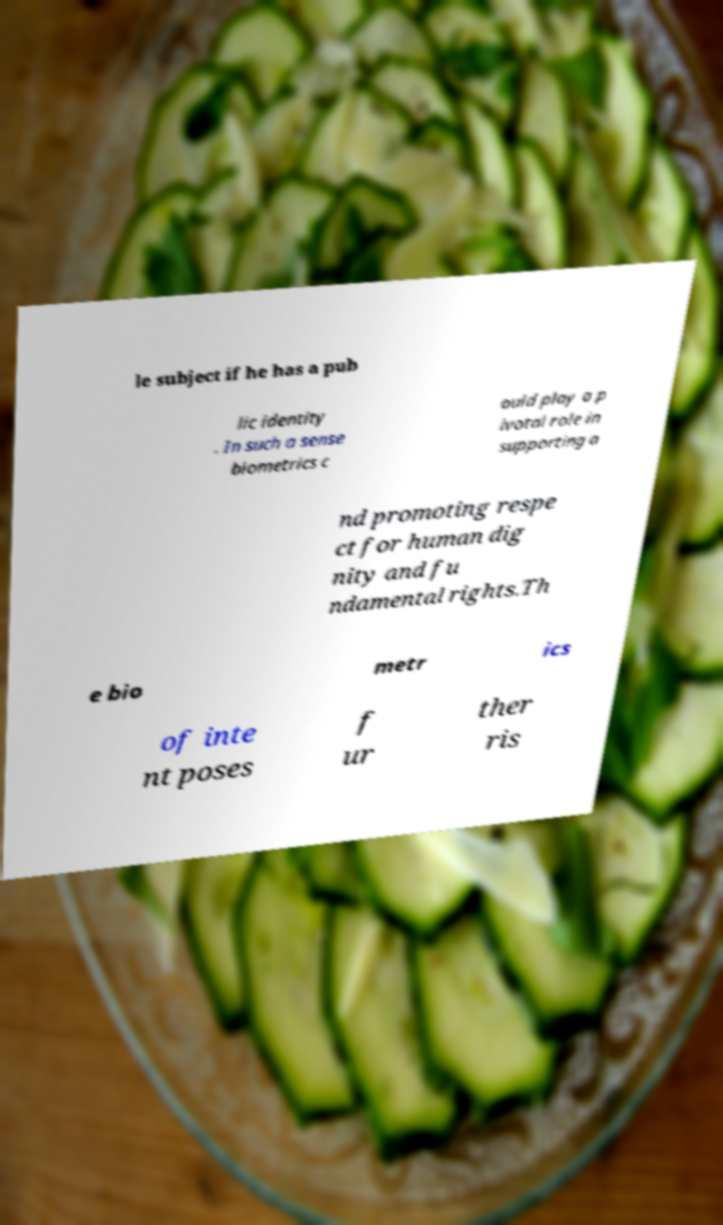Could you assist in decoding the text presented in this image and type it out clearly? le subject if he has a pub lic identity . In such a sense biometrics c ould play a p ivotal role in supporting a nd promoting respe ct for human dig nity and fu ndamental rights.Th e bio metr ics of inte nt poses f ur ther ris 